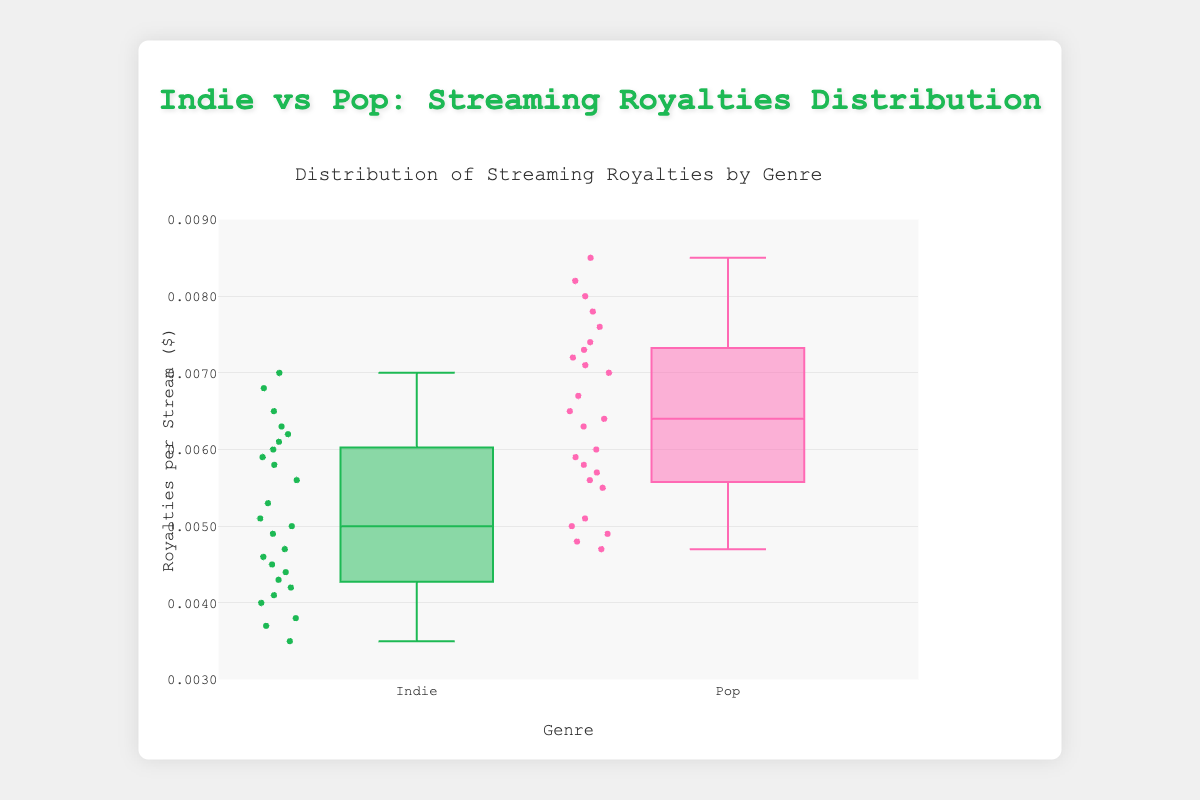What is the title of the plot? The plot title is usually prominently displayed at the top of the figure. In this case, it is written as: "Indie vs Pop: Streaming Royalties Distribution".
Answer: Indie vs Pop: Streaming Royalties Distribution What is the median value for the 'Pop' genre? The median value can be identified from the box plot's central line. For the Pop genre, it lies around the central mark on the y-axis. From the provided data, the median values are 0.0065, 0.0063, 0.0067, 0.0060, and 0.0064. Taking an average of these gives an overall median around 0.0064.
Answer: 0.0064 What genre has a higher interquartile range (IQR)? IQR is calculated as Q3 - Q1. For Indie, the IQR values are 0.0056-0.0042, 0.0060-0.0043, 0.0058-0.0044, 0.0062-0.0045, and 0.0059-0.0046. Averaging these gives an approximate IQR of 0.0016. For Pop, the IQR values are 0.0070-0.0055, 0.0072-0.0056, 0.0074-0.0057, 0.0071-0.0058, and 0.0073-0.0059. Averaging these gives an approximate IQR of 0.0015. Comparing these, Indie has a slightly higher IQR.
Answer: Indie Which genre has the highest maximum royalties per stream? The maximum value on the box plot is indicated by the top whisker. For Indie, the maximum values are 0.0065, 0.0061, 0.0063, 0.0068, and 0.0070. For Pop, the maximum values are 0.0080, 0.0078, 0.0076, 0.0082, and 0.0085. It is clear that Pop has the highest maximum value of 0.0085.
Answer: Pop Compare the median royalties per stream between Indie and Pop. Which one is higher? The median value is indicated by the line inside the box. For Indie, the median values are 0.0051, 0.0049, 0.0053, 0.0047, and 0.0050. For Pop, the median values are 0.0065, 0.0063, 0.0067, 0.0060, and 0.0064. It is clear that for all instances, Pop has higher median values compared to Indie.
Answer: Pop Between Indie and Pop, which genre has more spread in their royalty data? The spread can be evaluated by comparing the ranges (max - min) of the data. For Indie, the range values are 0.0065-0.0035, 0.0061-0.0038, 0.0063-0.0041, 0.0068-0.0040, and 0.0070-0.0037. For Pop, the range values are 0.0080-0.0048, 0.0078-0.0049, 0.0076-0.0050, 0.0082-0.0047, and 0.0085-0.0051. Calculating these ranges, Pop has a generally broader spread in data compared to Indie.
Answer: Pop What is the y-axis title of the plot? The y-axis title describes what the data represents per unit on this axis, indicated as 'Royalties per Stream ($)'.
Answer: Royalties per Stream ($) What is the minimum royalty value for the Indie genre according to the plot? The minimum value in a box plot is represented by the bottom whisker. For Indie, the minimum values are 0.0035, 0.0038, 0.0041, 0.0040, and 0.0037. The overall minimum value among these is 0.0035.
Answer: 0.0035 